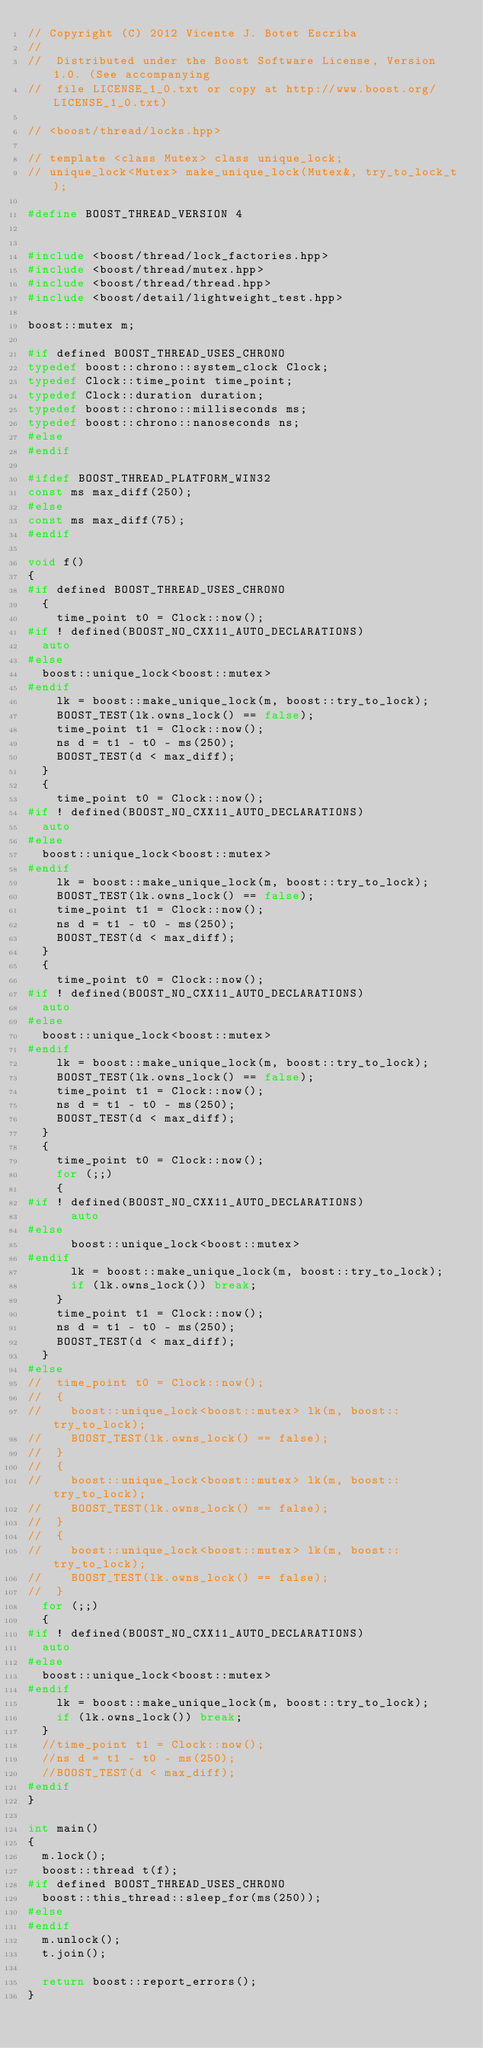<code> <loc_0><loc_0><loc_500><loc_500><_C++_>// Copyright (C) 2012 Vicente J. Botet Escriba
//
//  Distributed under the Boost Software License, Version 1.0. (See accompanying
//  file LICENSE_1_0.txt or copy at http://www.boost.org/LICENSE_1_0.txt)

// <boost/thread/locks.hpp>

// template <class Mutex> class unique_lock;
// unique_lock<Mutex> make_unique_lock(Mutex&, try_to_lock_t);

#define BOOST_THREAD_VERSION 4


#include <boost/thread/lock_factories.hpp>
#include <boost/thread/mutex.hpp>
#include <boost/thread/thread.hpp>
#include <boost/detail/lightweight_test.hpp>

boost::mutex m;

#if defined BOOST_THREAD_USES_CHRONO
typedef boost::chrono::system_clock Clock;
typedef Clock::time_point time_point;
typedef Clock::duration duration;
typedef boost::chrono::milliseconds ms;
typedef boost::chrono::nanoseconds ns;
#else
#endif

#ifdef BOOST_THREAD_PLATFORM_WIN32
const ms max_diff(250);
#else
const ms max_diff(75);
#endif

void f()
{
#if defined BOOST_THREAD_USES_CHRONO
  {
    time_point t0 = Clock::now();
#if ! defined(BOOST_NO_CXX11_AUTO_DECLARATIONS)
  auto
#else
  boost::unique_lock<boost::mutex>
#endif
    lk = boost::make_unique_lock(m, boost::try_to_lock);
    BOOST_TEST(lk.owns_lock() == false);
    time_point t1 = Clock::now();
    ns d = t1 - t0 - ms(250);
    BOOST_TEST(d < max_diff);
  }
  {
    time_point t0 = Clock::now();
#if ! defined(BOOST_NO_CXX11_AUTO_DECLARATIONS)
  auto
#else
  boost::unique_lock<boost::mutex>
#endif
    lk = boost::make_unique_lock(m, boost::try_to_lock);
    BOOST_TEST(lk.owns_lock() == false);
    time_point t1 = Clock::now();
    ns d = t1 - t0 - ms(250);
    BOOST_TEST(d < max_diff);
  }
  {
    time_point t0 = Clock::now();
#if ! defined(BOOST_NO_CXX11_AUTO_DECLARATIONS)
  auto
#else
  boost::unique_lock<boost::mutex>
#endif
    lk = boost::make_unique_lock(m, boost::try_to_lock);
    BOOST_TEST(lk.owns_lock() == false);
    time_point t1 = Clock::now();
    ns d = t1 - t0 - ms(250);
    BOOST_TEST(d < max_diff);
  }
  {
    time_point t0 = Clock::now();
    for (;;)
    {
#if ! defined(BOOST_NO_CXX11_AUTO_DECLARATIONS)
      auto
#else
      boost::unique_lock<boost::mutex>
#endif
      lk = boost::make_unique_lock(m, boost::try_to_lock);
      if (lk.owns_lock()) break;
    }
    time_point t1 = Clock::now();
    ns d = t1 - t0 - ms(250);
    BOOST_TEST(d < max_diff);
  }
#else
//  time_point t0 = Clock::now();
//  {
//    boost::unique_lock<boost::mutex> lk(m, boost::try_to_lock);
//    BOOST_TEST(lk.owns_lock() == false);
//  }
//  {
//    boost::unique_lock<boost::mutex> lk(m, boost::try_to_lock);
//    BOOST_TEST(lk.owns_lock() == false);
//  }
//  {
//    boost::unique_lock<boost::mutex> lk(m, boost::try_to_lock);
//    BOOST_TEST(lk.owns_lock() == false);
//  }
  for (;;)
  {
#if ! defined(BOOST_NO_CXX11_AUTO_DECLARATIONS)
  auto
#else
  boost::unique_lock<boost::mutex>
#endif
    lk = boost::make_unique_lock(m, boost::try_to_lock);
    if (lk.owns_lock()) break;
  }
  //time_point t1 = Clock::now();
  //ns d = t1 - t0 - ms(250);
  //BOOST_TEST(d < max_diff);
#endif
}

int main()
{
  m.lock();
  boost::thread t(f);
#if defined BOOST_THREAD_USES_CHRONO
  boost::this_thread::sleep_for(ms(250));
#else
#endif
  m.unlock();
  t.join();

  return boost::report_errors();
}
</code> 